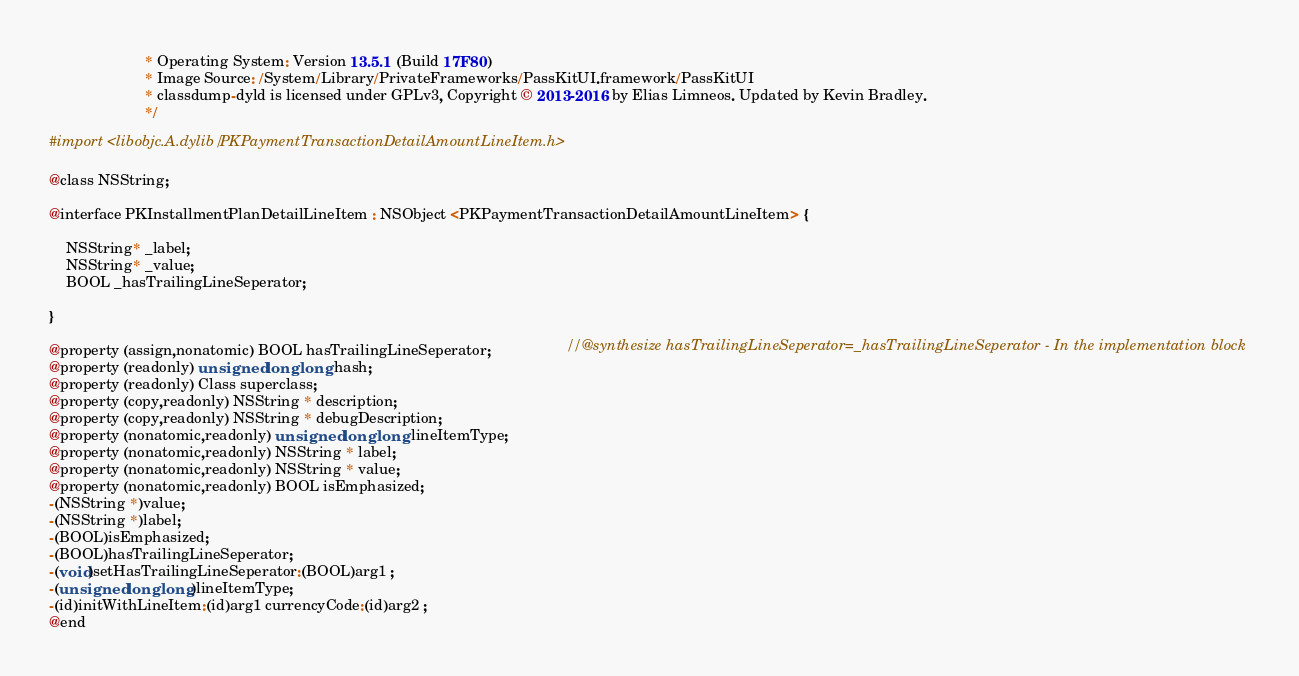<code> <loc_0><loc_0><loc_500><loc_500><_C_>                       * Operating System: Version 13.5.1 (Build 17F80)
                       * Image Source: /System/Library/PrivateFrameworks/PassKitUI.framework/PassKitUI
                       * classdump-dyld is licensed under GPLv3, Copyright © 2013-2016 by Elias Limneos. Updated by Kevin Bradley.
                       */

#import <libobjc.A.dylib/PKPaymentTransactionDetailAmountLineItem.h>

@class NSString;

@interface PKInstallmentPlanDetailLineItem : NSObject <PKPaymentTransactionDetailAmountLineItem> {

	NSString* _label;
	NSString* _value;
	BOOL _hasTrailingLineSeperator;

}

@property (assign,nonatomic) BOOL hasTrailingLineSeperator;                  //@synthesize hasTrailingLineSeperator=_hasTrailingLineSeperator - In the implementation block
@property (readonly) unsigned long long hash; 
@property (readonly) Class superclass; 
@property (copy,readonly) NSString * description; 
@property (copy,readonly) NSString * debugDescription; 
@property (nonatomic,readonly) unsigned long long lineItemType; 
@property (nonatomic,readonly) NSString * label; 
@property (nonatomic,readonly) NSString * value; 
@property (nonatomic,readonly) BOOL isEmphasized; 
-(NSString *)value;
-(NSString *)label;
-(BOOL)isEmphasized;
-(BOOL)hasTrailingLineSeperator;
-(void)setHasTrailingLineSeperator:(BOOL)arg1 ;
-(unsigned long long)lineItemType;
-(id)initWithLineItem:(id)arg1 currencyCode:(id)arg2 ;
@end

</code> 